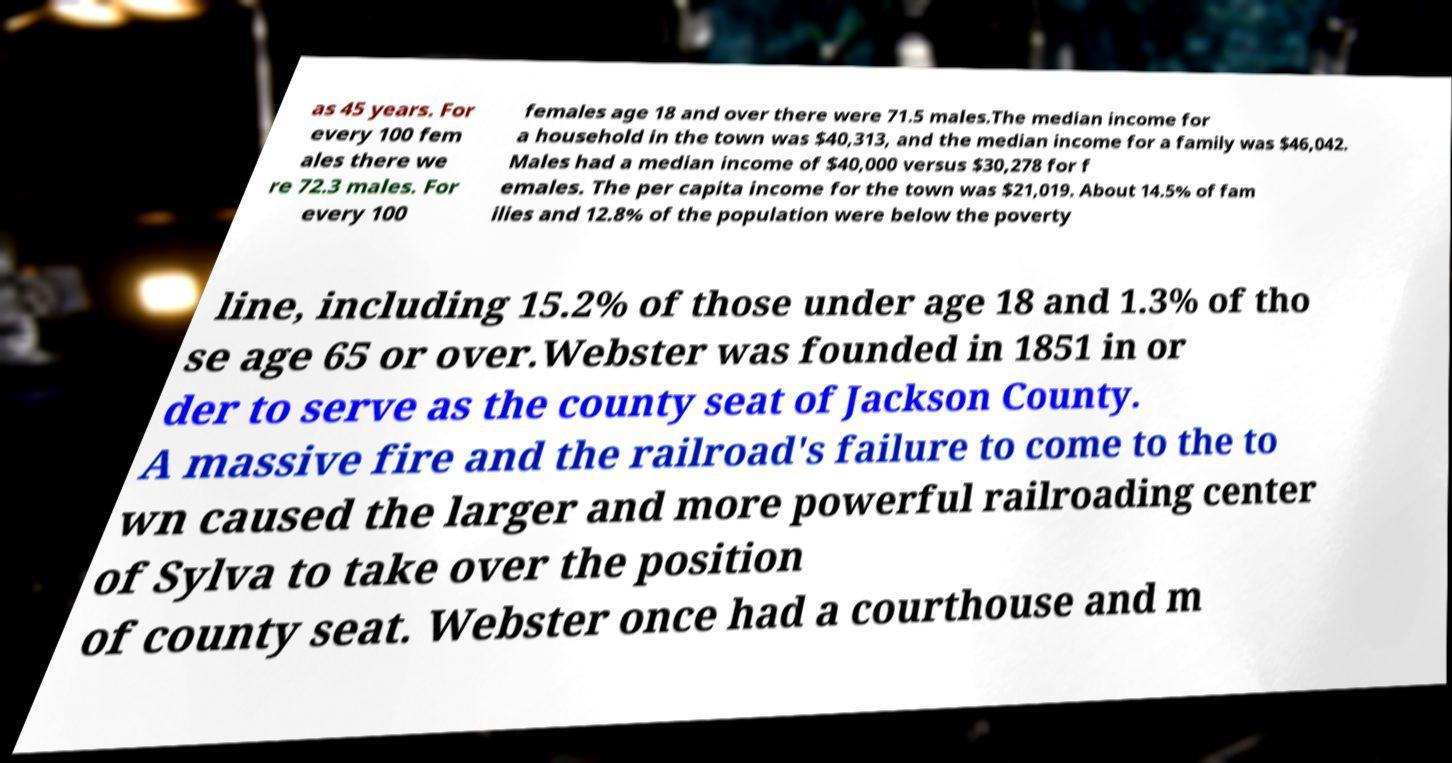For documentation purposes, I need the text within this image transcribed. Could you provide that? as 45 years. For every 100 fem ales there we re 72.3 males. For every 100 females age 18 and over there were 71.5 males.The median income for a household in the town was $40,313, and the median income for a family was $46,042. Males had a median income of $40,000 versus $30,278 for f emales. The per capita income for the town was $21,019. About 14.5% of fam ilies and 12.8% of the population were below the poverty line, including 15.2% of those under age 18 and 1.3% of tho se age 65 or over.Webster was founded in 1851 in or der to serve as the county seat of Jackson County. A massive fire and the railroad's failure to come to the to wn caused the larger and more powerful railroading center of Sylva to take over the position of county seat. Webster once had a courthouse and m 